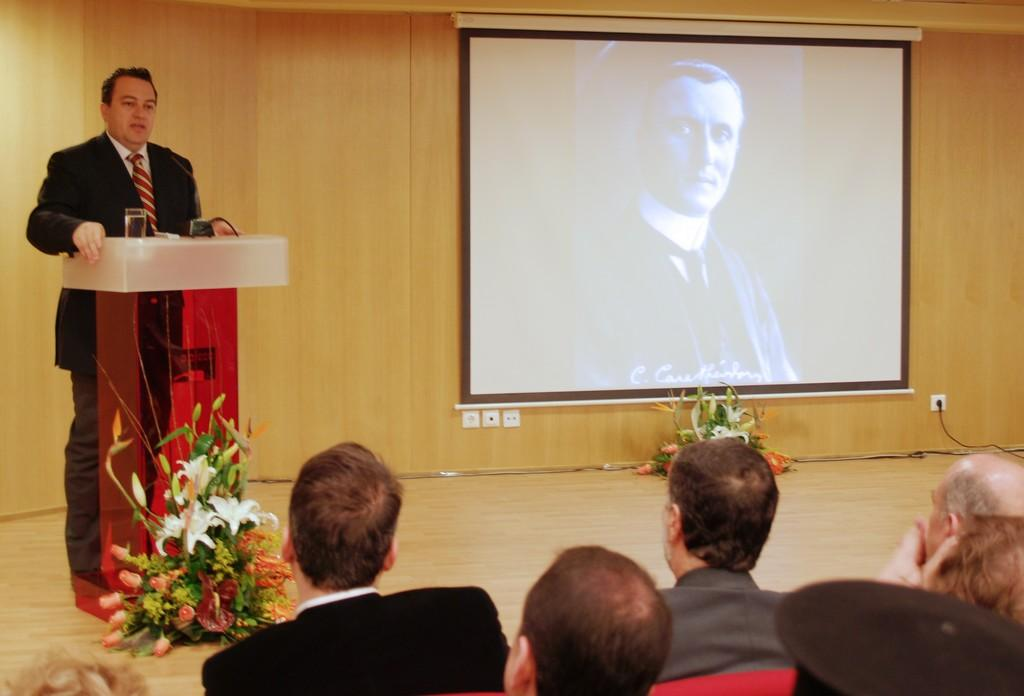What are the people in the image doing? There is a group of people sitting in the image. What can be seen besides the people in the image? There are flower bouquets and a screen visible in the image. What is the person standing near in the image? There is a person standing near a podium in the image. What type of linen is draped over the podium in the image? There is no linen draped over the podium in the image; it is not mentioned in the provided facts. 